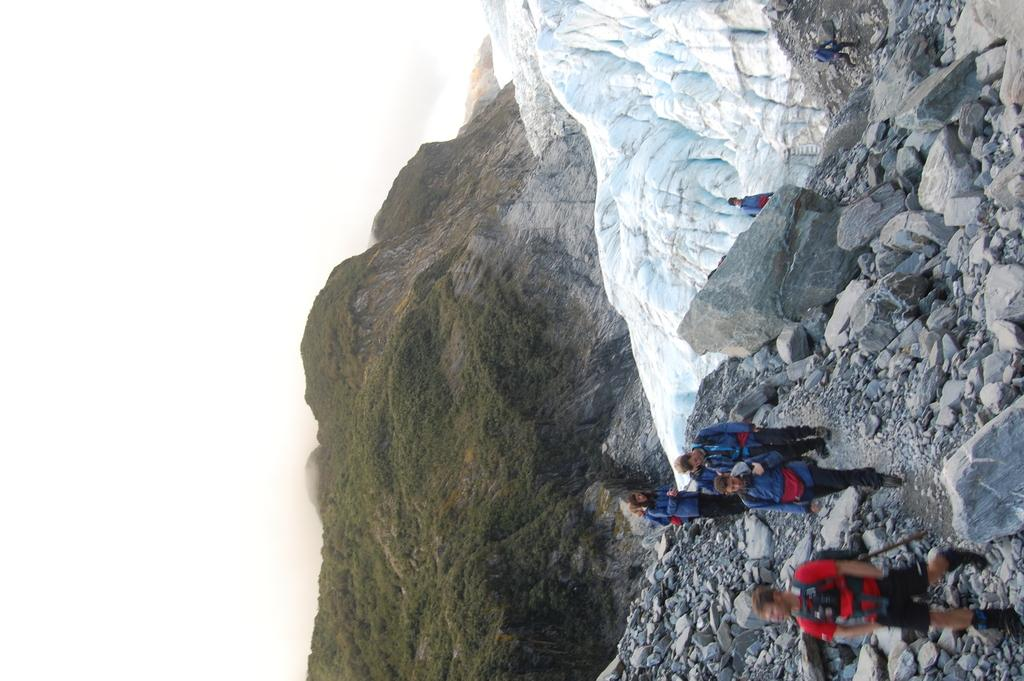What are the people in the image doing? The people in the image are walking. What type of natural features can be seen in the image? There are rocks, mountains, and trees in the image. Where are the trees and mountains located in the image? The trees and mountains are located in the center of the image. What type of print can be seen on the rocks in the image? There is no print visible on the rocks in the image. How many buttons are present on the trees in the image? There are no buttons present on the trees in the image. 